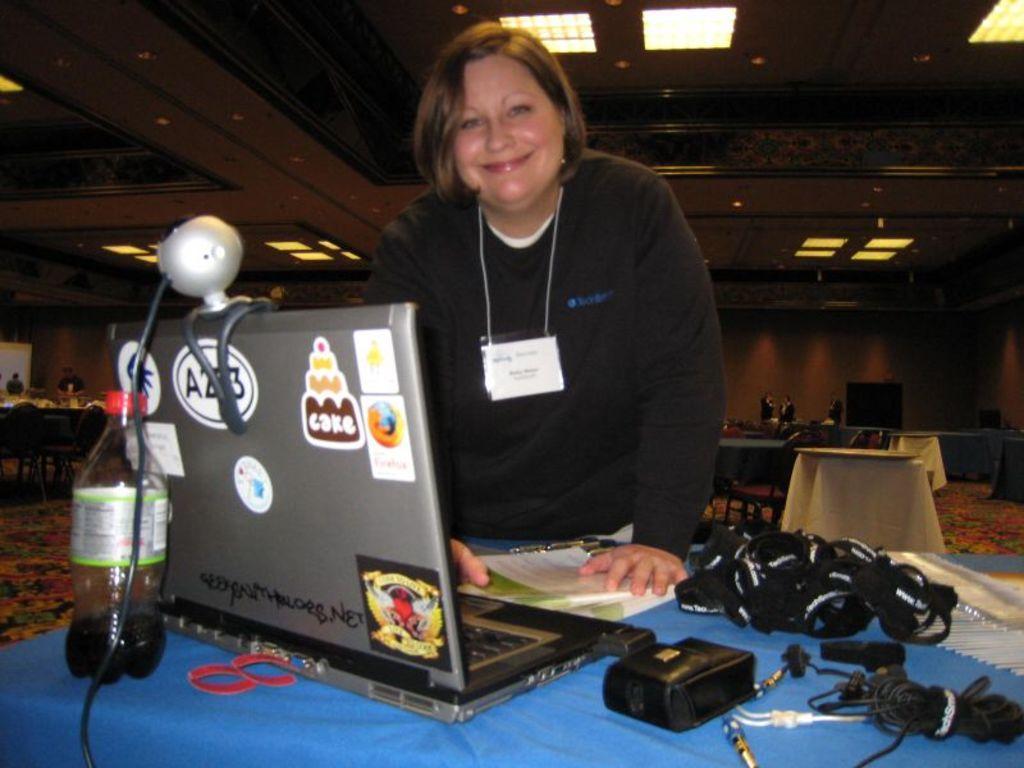Describe this image in one or two sentences. In this image there is a woman standing in front of a table with a smile on her face, on the table there is a laptop, a bottle of coke, and cables and other stuff, behind the women there are a few chairs and tables and there are few other person's standing. 